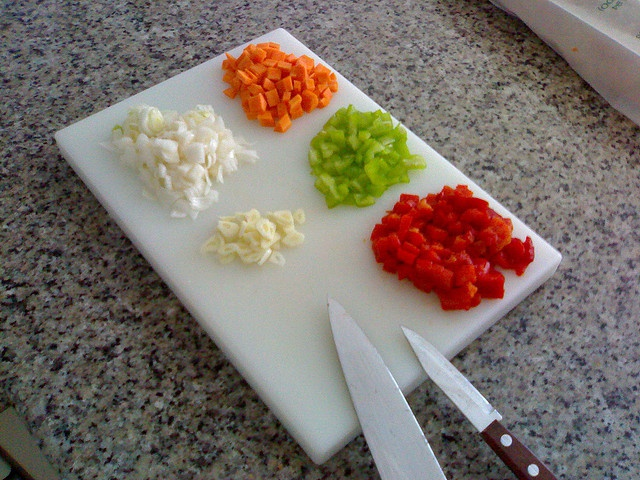Describe the objects in this image and their specific colors. I can see dining table in gray, darkgray, black, maroon, and darkgreen tones, knife in gray, darkgray, lavender, and lightblue tones, carrot in gray, red, and brown tones, and knife in gray, lightblue, darkgray, lavender, and maroon tones in this image. 